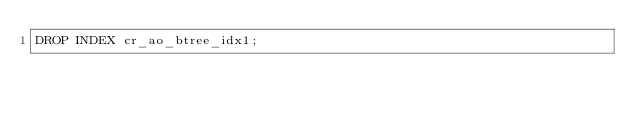<code> <loc_0><loc_0><loc_500><loc_500><_SQL_>DROP INDEX cr_ao_btree_idx1; 
</code> 